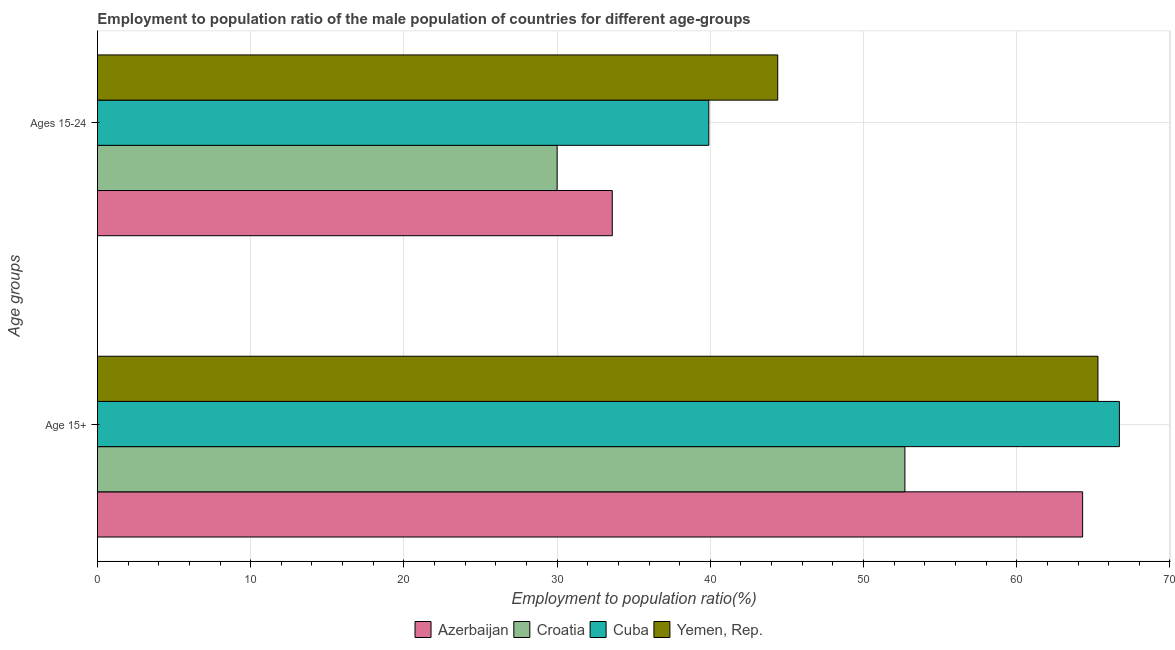How many different coloured bars are there?
Offer a terse response. 4. Are the number of bars per tick equal to the number of legend labels?
Ensure brevity in your answer.  Yes. Are the number of bars on each tick of the Y-axis equal?
Offer a terse response. Yes. How many bars are there on the 2nd tick from the top?
Offer a very short reply. 4. How many bars are there on the 1st tick from the bottom?
Offer a terse response. 4. What is the label of the 1st group of bars from the top?
Your answer should be very brief. Ages 15-24. What is the employment to population ratio(age 15-24) in Yemen, Rep.?
Make the answer very short. 44.4. Across all countries, what is the maximum employment to population ratio(age 15+)?
Your answer should be very brief. 66.7. Across all countries, what is the minimum employment to population ratio(age 15-24)?
Your answer should be compact. 30. In which country was the employment to population ratio(age 15-24) maximum?
Provide a short and direct response. Yemen, Rep. In which country was the employment to population ratio(age 15+) minimum?
Keep it short and to the point. Croatia. What is the total employment to population ratio(age 15+) in the graph?
Make the answer very short. 249. What is the difference between the employment to population ratio(age 15-24) in Croatia and that in Yemen, Rep.?
Provide a succinct answer. -14.4. What is the difference between the employment to population ratio(age 15-24) in Cuba and the employment to population ratio(age 15+) in Croatia?
Make the answer very short. -12.8. What is the average employment to population ratio(age 15-24) per country?
Provide a short and direct response. 36.98. What is the difference between the employment to population ratio(age 15+) and employment to population ratio(age 15-24) in Azerbaijan?
Offer a terse response. 30.7. In how many countries, is the employment to population ratio(age 15-24) greater than 50 %?
Your answer should be very brief. 0. What is the ratio of the employment to population ratio(age 15-24) in Yemen, Rep. to that in Cuba?
Provide a short and direct response. 1.11. Is the employment to population ratio(age 15+) in Yemen, Rep. less than that in Croatia?
Ensure brevity in your answer.  No. In how many countries, is the employment to population ratio(age 15-24) greater than the average employment to population ratio(age 15-24) taken over all countries?
Your answer should be compact. 2. What does the 4th bar from the top in Age 15+ represents?
Your response must be concise. Azerbaijan. What does the 4th bar from the bottom in Ages 15-24 represents?
Your answer should be very brief. Yemen, Rep. Are all the bars in the graph horizontal?
Provide a succinct answer. Yes. How many countries are there in the graph?
Ensure brevity in your answer.  4. Does the graph contain grids?
Your response must be concise. Yes. What is the title of the graph?
Your answer should be compact. Employment to population ratio of the male population of countries for different age-groups. Does "Namibia" appear as one of the legend labels in the graph?
Give a very brief answer. No. What is the label or title of the Y-axis?
Your answer should be very brief. Age groups. What is the Employment to population ratio(%) in Azerbaijan in Age 15+?
Your answer should be very brief. 64.3. What is the Employment to population ratio(%) of Croatia in Age 15+?
Your response must be concise. 52.7. What is the Employment to population ratio(%) of Cuba in Age 15+?
Ensure brevity in your answer.  66.7. What is the Employment to population ratio(%) in Yemen, Rep. in Age 15+?
Give a very brief answer. 65.3. What is the Employment to population ratio(%) of Azerbaijan in Ages 15-24?
Make the answer very short. 33.6. What is the Employment to population ratio(%) in Croatia in Ages 15-24?
Your response must be concise. 30. What is the Employment to population ratio(%) of Cuba in Ages 15-24?
Your answer should be very brief. 39.9. What is the Employment to population ratio(%) of Yemen, Rep. in Ages 15-24?
Offer a terse response. 44.4. Across all Age groups, what is the maximum Employment to population ratio(%) of Azerbaijan?
Your answer should be very brief. 64.3. Across all Age groups, what is the maximum Employment to population ratio(%) in Croatia?
Provide a short and direct response. 52.7. Across all Age groups, what is the maximum Employment to population ratio(%) in Cuba?
Ensure brevity in your answer.  66.7. Across all Age groups, what is the maximum Employment to population ratio(%) in Yemen, Rep.?
Offer a terse response. 65.3. Across all Age groups, what is the minimum Employment to population ratio(%) in Azerbaijan?
Offer a very short reply. 33.6. Across all Age groups, what is the minimum Employment to population ratio(%) of Cuba?
Keep it short and to the point. 39.9. Across all Age groups, what is the minimum Employment to population ratio(%) of Yemen, Rep.?
Your answer should be very brief. 44.4. What is the total Employment to population ratio(%) of Azerbaijan in the graph?
Provide a succinct answer. 97.9. What is the total Employment to population ratio(%) in Croatia in the graph?
Offer a terse response. 82.7. What is the total Employment to population ratio(%) in Cuba in the graph?
Make the answer very short. 106.6. What is the total Employment to population ratio(%) of Yemen, Rep. in the graph?
Provide a succinct answer. 109.7. What is the difference between the Employment to population ratio(%) in Azerbaijan in Age 15+ and that in Ages 15-24?
Your response must be concise. 30.7. What is the difference between the Employment to population ratio(%) of Croatia in Age 15+ and that in Ages 15-24?
Your answer should be very brief. 22.7. What is the difference between the Employment to population ratio(%) of Cuba in Age 15+ and that in Ages 15-24?
Keep it short and to the point. 26.8. What is the difference between the Employment to population ratio(%) of Yemen, Rep. in Age 15+ and that in Ages 15-24?
Provide a short and direct response. 20.9. What is the difference between the Employment to population ratio(%) in Azerbaijan in Age 15+ and the Employment to population ratio(%) in Croatia in Ages 15-24?
Offer a very short reply. 34.3. What is the difference between the Employment to population ratio(%) in Azerbaijan in Age 15+ and the Employment to population ratio(%) in Cuba in Ages 15-24?
Provide a short and direct response. 24.4. What is the difference between the Employment to population ratio(%) in Azerbaijan in Age 15+ and the Employment to population ratio(%) in Yemen, Rep. in Ages 15-24?
Give a very brief answer. 19.9. What is the difference between the Employment to population ratio(%) of Croatia in Age 15+ and the Employment to population ratio(%) of Cuba in Ages 15-24?
Your answer should be very brief. 12.8. What is the difference between the Employment to population ratio(%) of Croatia in Age 15+ and the Employment to population ratio(%) of Yemen, Rep. in Ages 15-24?
Offer a very short reply. 8.3. What is the difference between the Employment to population ratio(%) of Cuba in Age 15+ and the Employment to population ratio(%) of Yemen, Rep. in Ages 15-24?
Provide a short and direct response. 22.3. What is the average Employment to population ratio(%) of Azerbaijan per Age groups?
Offer a very short reply. 48.95. What is the average Employment to population ratio(%) of Croatia per Age groups?
Give a very brief answer. 41.35. What is the average Employment to population ratio(%) in Cuba per Age groups?
Your answer should be compact. 53.3. What is the average Employment to population ratio(%) in Yemen, Rep. per Age groups?
Provide a short and direct response. 54.85. What is the difference between the Employment to population ratio(%) of Azerbaijan and Employment to population ratio(%) of Croatia in Age 15+?
Your response must be concise. 11.6. What is the difference between the Employment to population ratio(%) in Azerbaijan and Employment to population ratio(%) in Cuba in Age 15+?
Give a very brief answer. -2.4. What is the difference between the Employment to population ratio(%) of Azerbaijan and Employment to population ratio(%) of Yemen, Rep. in Age 15+?
Your response must be concise. -1. What is the difference between the Employment to population ratio(%) of Croatia and Employment to population ratio(%) of Cuba in Age 15+?
Make the answer very short. -14. What is the difference between the Employment to population ratio(%) of Cuba and Employment to population ratio(%) of Yemen, Rep. in Age 15+?
Provide a short and direct response. 1.4. What is the difference between the Employment to population ratio(%) in Azerbaijan and Employment to population ratio(%) in Croatia in Ages 15-24?
Make the answer very short. 3.6. What is the difference between the Employment to population ratio(%) of Croatia and Employment to population ratio(%) of Cuba in Ages 15-24?
Give a very brief answer. -9.9. What is the difference between the Employment to population ratio(%) in Croatia and Employment to population ratio(%) in Yemen, Rep. in Ages 15-24?
Your answer should be very brief. -14.4. What is the difference between the Employment to population ratio(%) of Cuba and Employment to population ratio(%) of Yemen, Rep. in Ages 15-24?
Your answer should be compact. -4.5. What is the ratio of the Employment to population ratio(%) in Azerbaijan in Age 15+ to that in Ages 15-24?
Give a very brief answer. 1.91. What is the ratio of the Employment to population ratio(%) of Croatia in Age 15+ to that in Ages 15-24?
Offer a terse response. 1.76. What is the ratio of the Employment to population ratio(%) of Cuba in Age 15+ to that in Ages 15-24?
Offer a terse response. 1.67. What is the ratio of the Employment to population ratio(%) in Yemen, Rep. in Age 15+ to that in Ages 15-24?
Your answer should be compact. 1.47. What is the difference between the highest and the second highest Employment to population ratio(%) of Azerbaijan?
Offer a very short reply. 30.7. What is the difference between the highest and the second highest Employment to population ratio(%) in Croatia?
Give a very brief answer. 22.7. What is the difference between the highest and the second highest Employment to population ratio(%) in Cuba?
Offer a very short reply. 26.8. What is the difference between the highest and the second highest Employment to population ratio(%) of Yemen, Rep.?
Your answer should be compact. 20.9. What is the difference between the highest and the lowest Employment to population ratio(%) in Azerbaijan?
Keep it short and to the point. 30.7. What is the difference between the highest and the lowest Employment to population ratio(%) in Croatia?
Offer a terse response. 22.7. What is the difference between the highest and the lowest Employment to population ratio(%) in Cuba?
Your answer should be very brief. 26.8. What is the difference between the highest and the lowest Employment to population ratio(%) in Yemen, Rep.?
Provide a short and direct response. 20.9. 